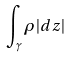<formula> <loc_0><loc_0><loc_500><loc_500>\int _ { \gamma } \rho | d z |</formula> 